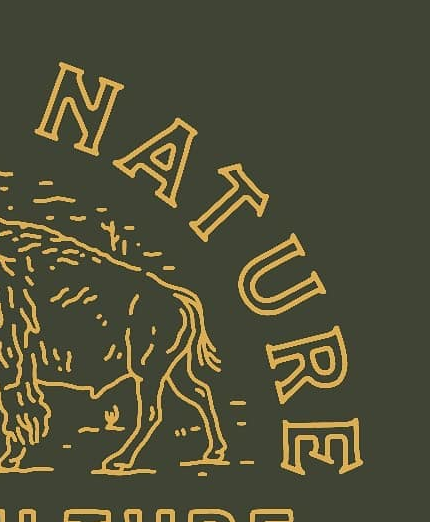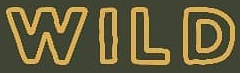Read the text content from these images in order, separated by a semicolon. NATURE; WILD 